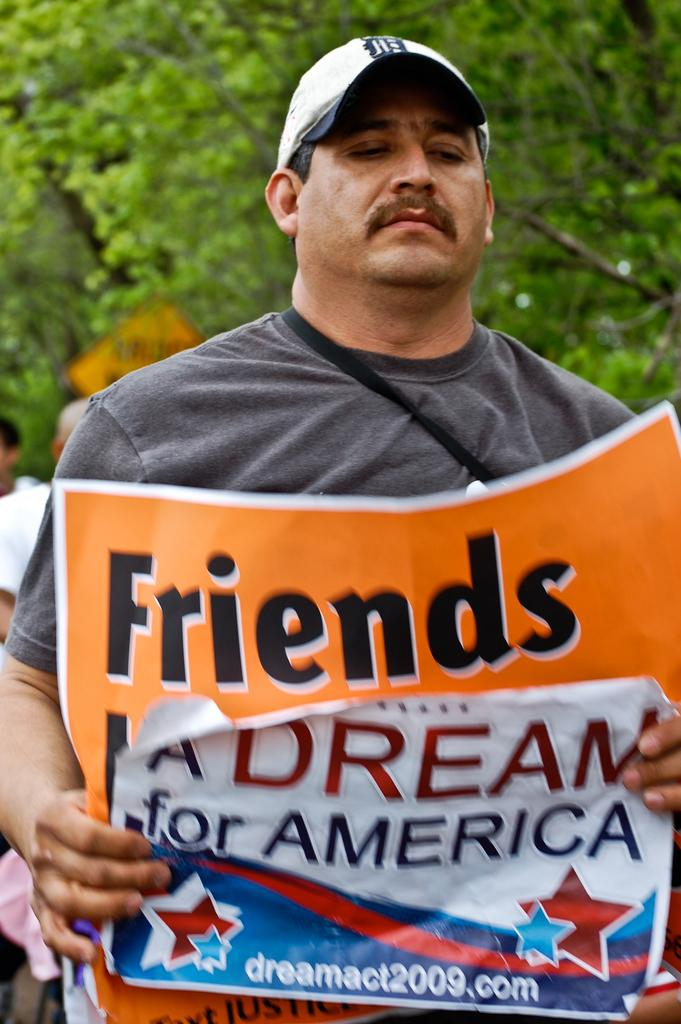<image>
Offer a succinct explanation of the picture presented. A man holds a sign that says, "A Dream for America" in front of another sign that says, "Friends". 